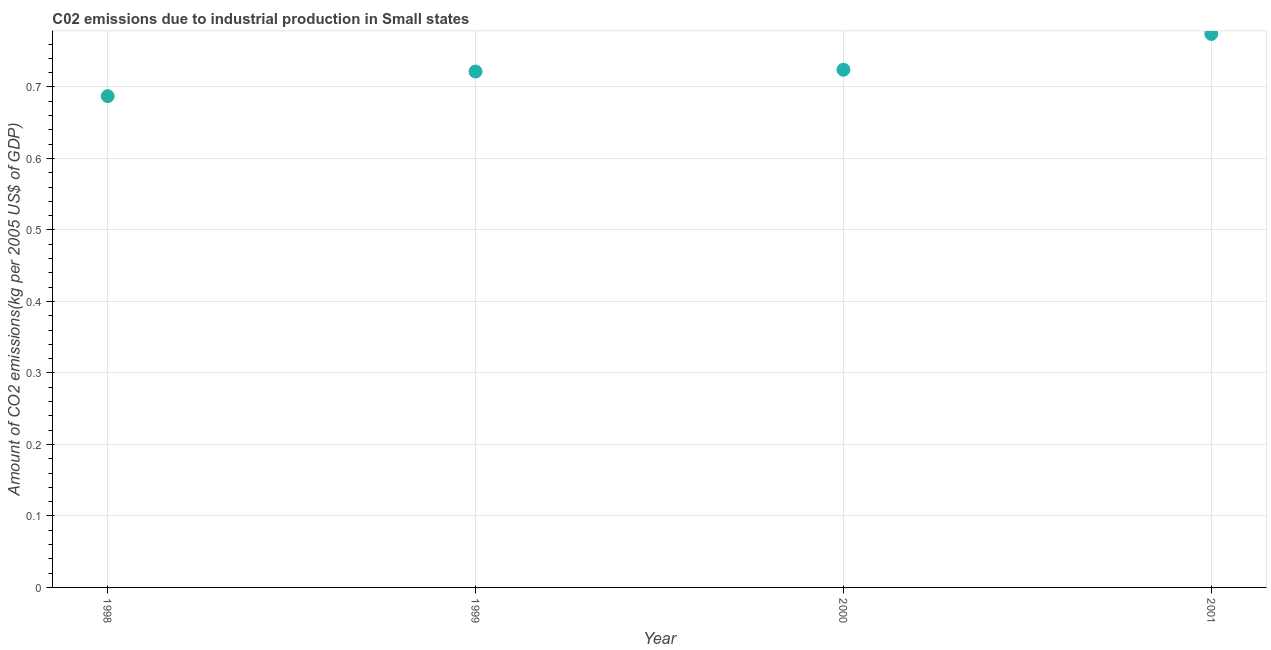What is the amount of co2 emissions in 1998?
Make the answer very short. 0.69. Across all years, what is the maximum amount of co2 emissions?
Offer a very short reply. 0.77. Across all years, what is the minimum amount of co2 emissions?
Provide a succinct answer. 0.69. In which year was the amount of co2 emissions maximum?
Give a very brief answer. 2001. What is the sum of the amount of co2 emissions?
Provide a short and direct response. 2.91. What is the difference between the amount of co2 emissions in 1998 and 1999?
Your answer should be very brief. -0.03. What is the average amount of co2 emissions per year?
Offer a very short reply. 0.73. What is the median amount of co2 emissions?
Keep it short and to the point. 0.72. In how many years, is the amount of co2 emissions greater than 0.68 kg per 2005 US$ of GDP?
Your answer should be compact. 4. What is the ratio of the amount of co2 emissions in 2000 to that in 2001?
Your response must be concise. 0.94. Is the amount of co2 emissions in 1998 less than that in 2000?
Ensure brevity in your answer.  Yes. What is the difference between the highest and the second highest amount of co2 emissions?
Ensure brevity in your answer.  0.05. What is the difference between the highest and the lowest amount of co2 emissions?
Your answer should be very brief. 0.09. What is the difference between two consecutive major ticks on the Y-axis?
Give a very brief answer. 0.1. Are the values on the major ticks of Y-axis written in scientific E-notation?
Give a very brief answer. No. What is the title of the graph?
Ensure brevity in your answer.  C02 emissions due to industrial production in Small states. What is the label or title of the Y-axis?
Keep it short and to the point. Amount of CO2 emissions(kg per 2005 US$ of GDP). What is the Amount of CO2 emissions(kg per 2005 US$ of GDP) in 1998?
Your answer should be very brief. 0.69. What is the Amount of CO2 emissions(kg per 2005 US$ of GDP) in 1999?
Ensure brevity in your answer.  0.72. What is the Amount of CO2 emissions(kg per 2005 US$ of GDP) in 2000?
Ensure brevity in your answer.  0.72. What is the Amount of CO2 emissions(kg per 2005 US$ of GDP) in 2001?
Your response must be concise. 0.77. What is the difference between the Amount of CO2 emissions(kg per 2005 US$ of GDP) in 1998 and 1999?
Provide a succinct answer. -0.03. What is the difference between the Amount of CO2 emissions(kg per 2005 US$ of GDP) in 1998 and 2000?
Offer a terse response. -0.04. What is the difference between the Amount of CO2 emissions(kg per 2005 US$ of GDP) in 1998 and 2001?
Provide a succinct answer. -0.09. What is the difference between the Amount of CO2 emissions(kg per 2005 US$ of GDP) in 1999 and 2000?
Ensure brevity in your answer.  -0. What is the difference between the Amount of CO2 emissions(kg per 2005 US$ of GDP) in 1999 and 2001?
Your response must be concise. -0.05. What is the difference between the Amount of CO2 emissions(kg per 2005 US$ of GDP) in 2000 and 2001?
Offer a very short reply. -0.05. What is the ratio of the Amount of CO2 emissions(kg per 2005 US$ of GDP) in 1998 to that in 2000?
Provide a short and direct response. 0.95. What is the ratio of the Amount of CO2 emissions(kg per 2005 US$ of GDP) in 1998 to that in 2001?
Make the answer very short. 0.89. What is the ratio of the Amount of CO2 emissions(kg per 2005 US$ of GDP) in 1999 to that in 2000?
Ensure brevity in your answer.  1. What is the ratio of the Amount of CO2 emissions(kg per 2005 US$ of GDP) in 1999 to that in 2001?
Your answer should be compact. 0.93. What is the ratio of the Amount of CO2 emissions(kg per 2005 US$ of GDP) in 2000 to that in 2001?
Offer a terse response. 0.94. 